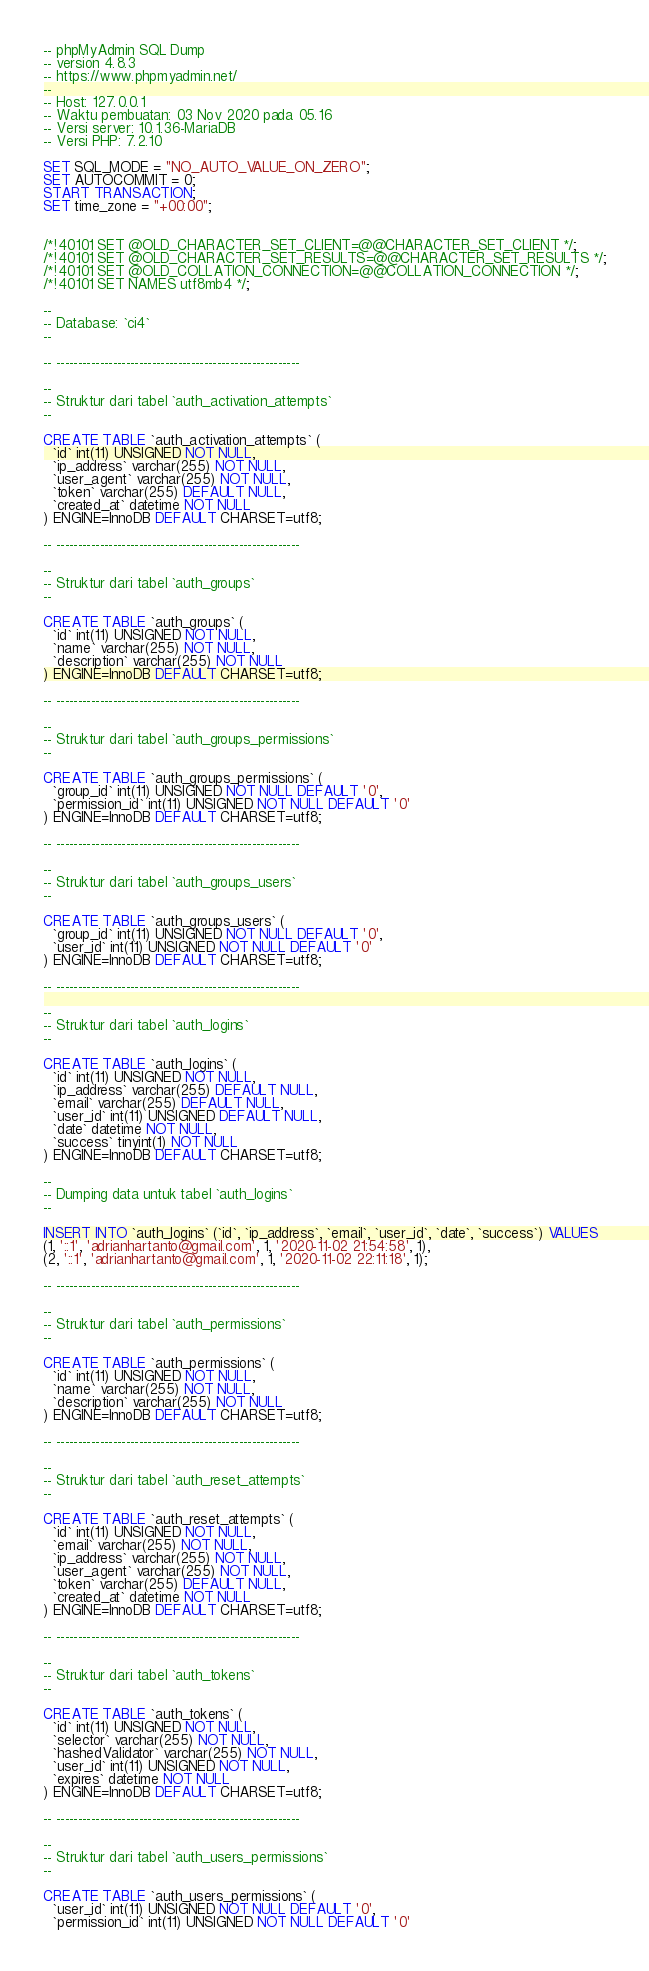Convert code to text. <code><loc_0><loc_0><loc_500><loc_500><_SQL_>-- phpMyAdmin SQL Dump
-- version 4.8.3
-- https://www.phpmyadmin.net/
--
-- Host: 127.0.0.1
-- Waktu pembuatan: 03 Nov 2020 pada 05.16
-- Versi server: 10.1.36-MariaDB
-- Versi PHP: 7.2.10

SET SQL_MODE = "NO_AUTO_VALUE_ON_ZERO";
SET AUTOCOMMIT = 0;
START TRANSACTION;
SET time_zone = "+00:00";


/*!40101 SET @OLD_CHARACTER_SET_CLIENT=@@CHARACTER_SET_CLIENT */;
/*!40101 SET @OLD_CHARACTER_SET_RESULTS=@@CHARACTER_SET_RESULTS */;
/*!40101 SET @OLD_COLLATION_CONNECTION=@@COLLATION_CONNECTION */;
/*!40101 SET NAMES utf8mb4 */;

--
-- Database: `ci4`
--

-- --------------------------------------------------------

--
-- Struktur dari tabel `auth_activation_attempts`
--

CREATE TABLE `auth_activation_attempts` (
  `id` int(11) UNSIGNED NOT NULL,
  `ip_address` varchar(255) NOT NULL,
  `user_agent` varchar(255) NOT NULL,
  `token` varchar(255) DEFAULT NULL,
  `created_at` datetime NOT NULL
) ENGINE=InnoDB DEFAULT CHARSET=utf8;

-- --------------------------------------------------------

--
-- Struktur dari tabel `auth_groups`
--

CREATE TABLE `auth_groups` (
  `id` int(11) UNSIGNED NOT NULL,
  `name` varchar(255) NOT NULL,
  `description` varchar(255) NOT NULL
) ENGINE=InnoDB DEFAULT CHARSET=utf8;

-- --------------------------------------------------------

--
-- Struktur dari tabel `auth_groups_permissions`
--

CREATE TABLE `auth_groups_permissions` (
  `group_id` int(11) UNSIGNED NOT NULL DEFAULT '0',
  `permission_id` int(11) UNSIGNED NOT NULL DEFAULT '0'
) ENGINE=InnoDB DEFAULT CHARSET=utf8;

-- --------------------------------------------------------

--
-- Struktur dari tabel `auth_groups_users`
--

CREATE TABLE `auth_groups_users` (
  `group_id` int(11) UNSIGNED NOT NULL DEFAULT '0',
  `user_id` int(11) UNSIGNED NOT NULL DEFAULT '0'
) ENGINE=InnoDB DEFAULT CHARSET=utf8;

-- --------------------------------------------------------

--
-- Struktur dari tabel `auth_logins`
--

CREATE TABLE `auth_logins` (
  `id` int(11) UNSIGNED NOT NULL,
  `ip_address` varchar(255) DEFAULT NULL,
  `email` varchar(255) DEFAULT NULL,
  `user_id` int(11) UNSIGNED DEFAULT NULL,
  `date` datetime NOT NULL,
  `success` tinyint(1) NOT NULL
) ENGINE=InnoDB DEFAULT CHARSET=utf8;

--
-- Dumping data untuk tabel `auth_logins`
--

INSERT INTO `auth_logins` (`id`, `ip_address`, `email`, `user_id`, `date`, `success`) VALUES
(1, '::1', 'adrianhartanto@gmail.com', 1, '2020-11-02 21:54:58', 1),
(2, '::1', 'adrianhartanto@gmail.com', 1, '2020-11-02 22:11:18', 1);

-- --------------------------------------------------------

--
-- Struktur dari tabel `auth_permissions`
--

CREATE TABLE `auth_permissions` (
  `id` int(11) UNSIGNED NOT NULL,
  `name` varchar(255) NOT NULL,
  `description` varchar(255) NOT NULL
) ENGINE=InnoDB DEFAULT CHARSET=utf8;

-- --------------------------------------------------------

--
-- Struktur dari tabel `auth_reset_attempts`
--

CREATE TABLE `auth_reset_attempts` (
  `id` int(11) UNSIGNED NOT NULL,
  `email` varchar(255) NOT NULL,
  `ip_address` varchar(255) NOT NULL,
  `user_agent` varchar(255) NOT NULL,
  `token` varchar(255) DEFAULT NULL,
  `created_at` datetime NOT NULL
) ENGINE=InnoDB DEFAULT CHARSET=utf8;

-- --------------------------------------------------------

--
-- Struktur dari tabel `auth_tokens`
--

CREATE TABLE `auth_tokens` (
  `id` int(11) UNSIGNED NOT NULL,
  `selector` varchar(255) NOT NULL,
  `hashedValidator` varchar(255) NOT NULL,
  `user_id` int(11) UNSIGNED NOT NULL,
  `expires` datetime NOT NULL
) ENGINE=InnoDB DEFAULT CHARSET=utf8;

-- --------------------------------------------------------

--
-- Struktur dari tabel `auth_users_permissions`
--

CREATE TABLE `auth_users_permissions` (
  `user_id` int(11) UNSIGNED NOT NULL DEFAULT '0',
  `permission_id` int(11) UNSIGNED NOT NULL DEFAULT '0'</code> 